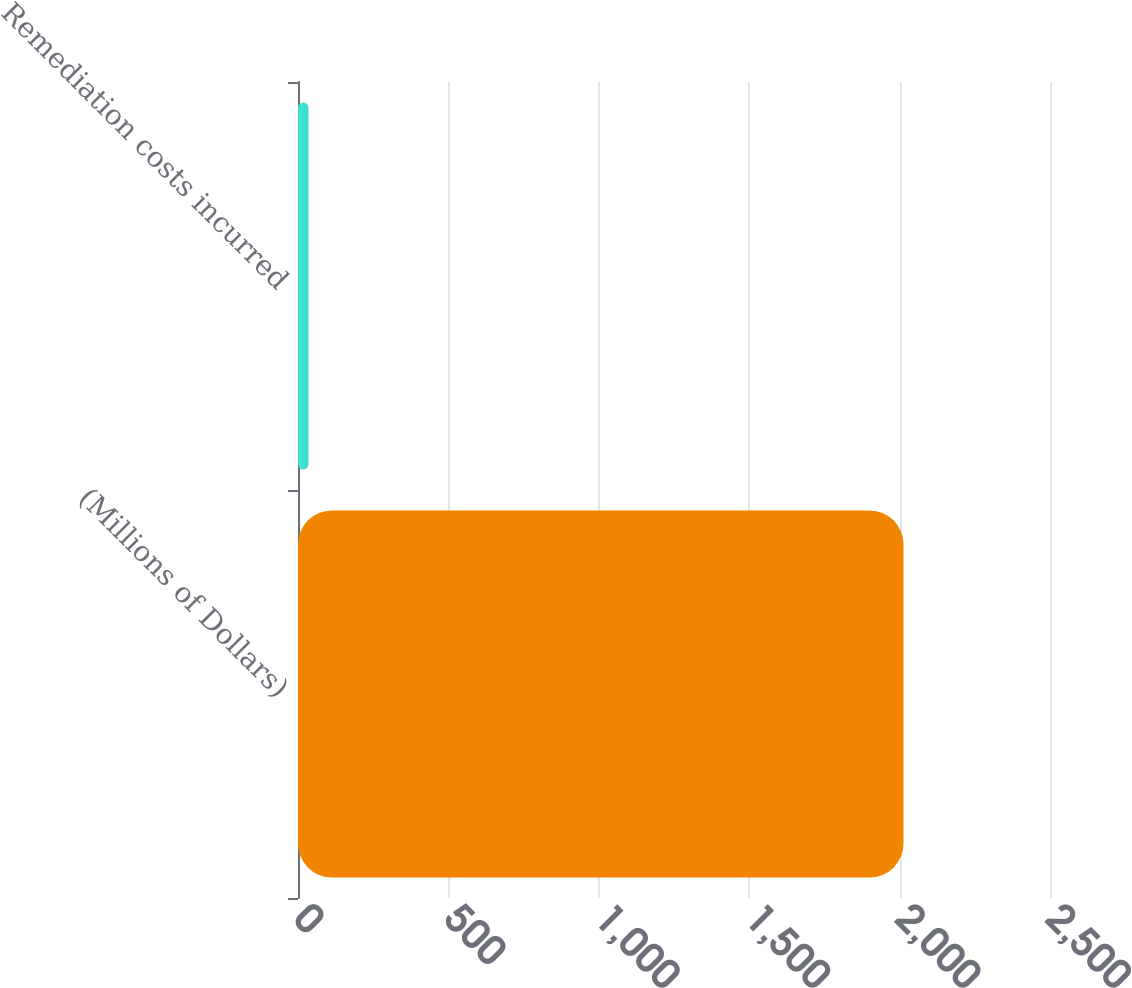Convert chart. <chart><loc_0><loc_0><loc_500><loc_500><bar_chart><fcel>(Millions of Dollars)<fcel>Remediation costs incurred<nl><fcel>2013<fcel>35<nl></chart> 